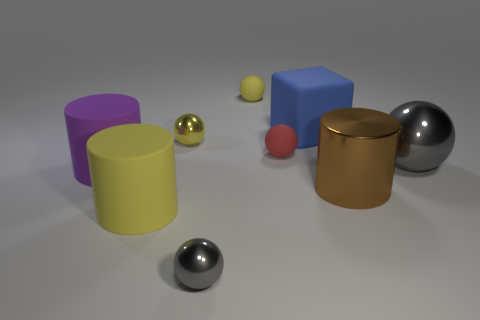Subtract 2 balls. How many balls are left? 3 Subtract all tiny yellow shiny spheres. How many spheres are left? 4 Subtract all red balls. How many balls are left? 4 Subtract all cyan balls. Subtract all brown cubes. How many balls are left? 5 Subtract all blocks. How many objects are left? 8 Add 2 brown cylinders. How many brown cylinders are left? 3 Add 8 large purple cylinders. How many large purple cylinders exist? 9 Subtract 1 red balls. How many objects are left? 8 Subtract all red rubber objects. Subtract all tiny metal balls. How many objects are left? 6 